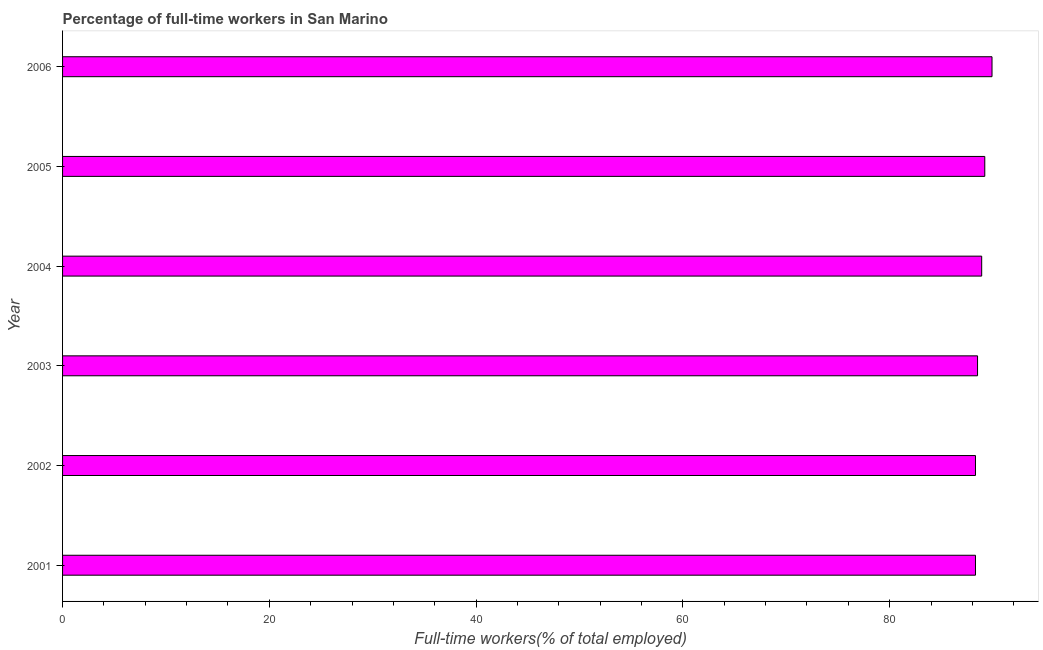Does the graph contain any zero values?
Make the answer very short. No. What is the title of the graph?
Your answer should be very brief. Percentage of full-time workers in San Marino. What is the label or title of the X-axis?
Your answer should be compact. Full-time workers(% of total employed). What is the percentage of full-time workers in 2002?
Make the answer very short. 88.3. Across all years, what is the maximum percentage of full-time workers?
Your answer should be compact. 89.9. Across all years, what is the minimum percentage of full-time workers?
Ensure brevity in your answer.  88.3. What is the sum of the percentage of full-time workers?
Make the answer very short. 533.1. What is the difference between the percentage of full-time workers in 2001 and 2003?
Ensure brevity in your answer.  -0.2. What is the average percentage of full-time workers per year?
Give a very brief answer. 88.85. What is the median percentage of full-time workers?
Ensure brevity in your answer.  88.7. In how many years, is the percentage of full-time workers greater than 84 %?
Give a very brief answer. 6. Do a majority of the years between 2006 and 2004 (inclusive) have percentage of full-time workers greater than 36 %?
Ensure brevity in your answer.  Yes. What is the ratio of the percentage of full-time workers in 2002 to that in 2006?
Provide a succinct answer. 0.98. Is the percentage of full-time workers in 2001 less than that in 2004?
Your answer should be compact. Yes. Is the difference between the percentage of full-time workers in 2001 and 2006 greater than the difference between any two years?
Your answer should be compact. Yes. Are all the bars in the graph horizontal?
Make the answer very short. Yes. How many years are there in the graph?
Give a very brief answer. 6. What is the Full-time workers(% of total employed) of 2001?
Your response must be concise. 88.3. What is the Full-time workers(% of total employed) in 2002?
Make the answer very short. 88.3. What is the Full-time workers(% of total employed) of 2003?
Ensure brevity in your answer.  88.5. What is the Full-time workers(% of total employed) of 2004?
Your answer should be very brief. 88.9. What is the Full-time workers(% of total employed) of 2005?
Provide a succinct answer. 89.2. What is the Full-time workers(% of total employed) of 2006?
Offer a very short reply. 89.9. What is the difference between the Full-time workers(% of total employed) in 2001 and 2003?
Provide a succinct answer. -0.2. What is the difference between the Full-time workers(% of total employed) in 2001 and 2004?
Your response must be concise. -0.6. What is the difference between the Full-time workers(% of total employed) in 2001 and 2005?
Your response must be concise. -0.9. What is the difference between the Full-time workers(% of total employed) in 2001 and 2006?
Ensure brevity in your answer.  -1.6. What is the difference between the Full-time workers(% of total employed) in 2002 and 2005?
Offer a terse response. -0.9. What is the difference between the Full-time workers(% of total employed) in 2002 and 2006?
Provide a short and direct response. -1.6. What is the difference between the Full-time workers(% of total employed) in 2003 and 2005?
Your response must be concise. -0.7. What is the difference between the Full-time workers(% of total employed) in 2003 and 2006?
Offer a very short reply. -1.4. What is the difference between the Full-time workers(% of total employed) in 2004 and 2006?
Offer a very short reply. -1. What is the ratio of the Full-time workers(% of total employed) in 2001 to that in 2002?
Make the answer very short. 1. What is the ratio of the Full-time workers(% of total employed) in 2001 to that in 2004?
Your answer should be compact. 0.99. What is the ratio of the Full-time workers(% of total employed) in 2001 to that in 2005?
Keep it short and to the point. 0.99. What is the ratio of the Full-time workers(% of total employed) in 2002 to that in 2003?
Your answer should be compact. 1. What is the ratio of the Full-time workers(% of total employed) in 2002 to that in 2004?
Provide a short and direct response. 0.99. What is the ratio of the Full-time workers(% of total employed) in 2002 to that in 2005?
Keep it short and to the point. 0.99. What is the ratio of the Full-time workers(% of total employed) in 2002 to that in 2006?
Offer a terse response. 0.98. What is the ratio of the Full-time workers(% of total employed) in 2004 to that in 2005?
Give a very brief answer. 1. 